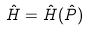<formula> <loc_0><loc_0><loc_500><loc_500>\hat { H } = \hat { H } ( \hat { P } )</formula> 